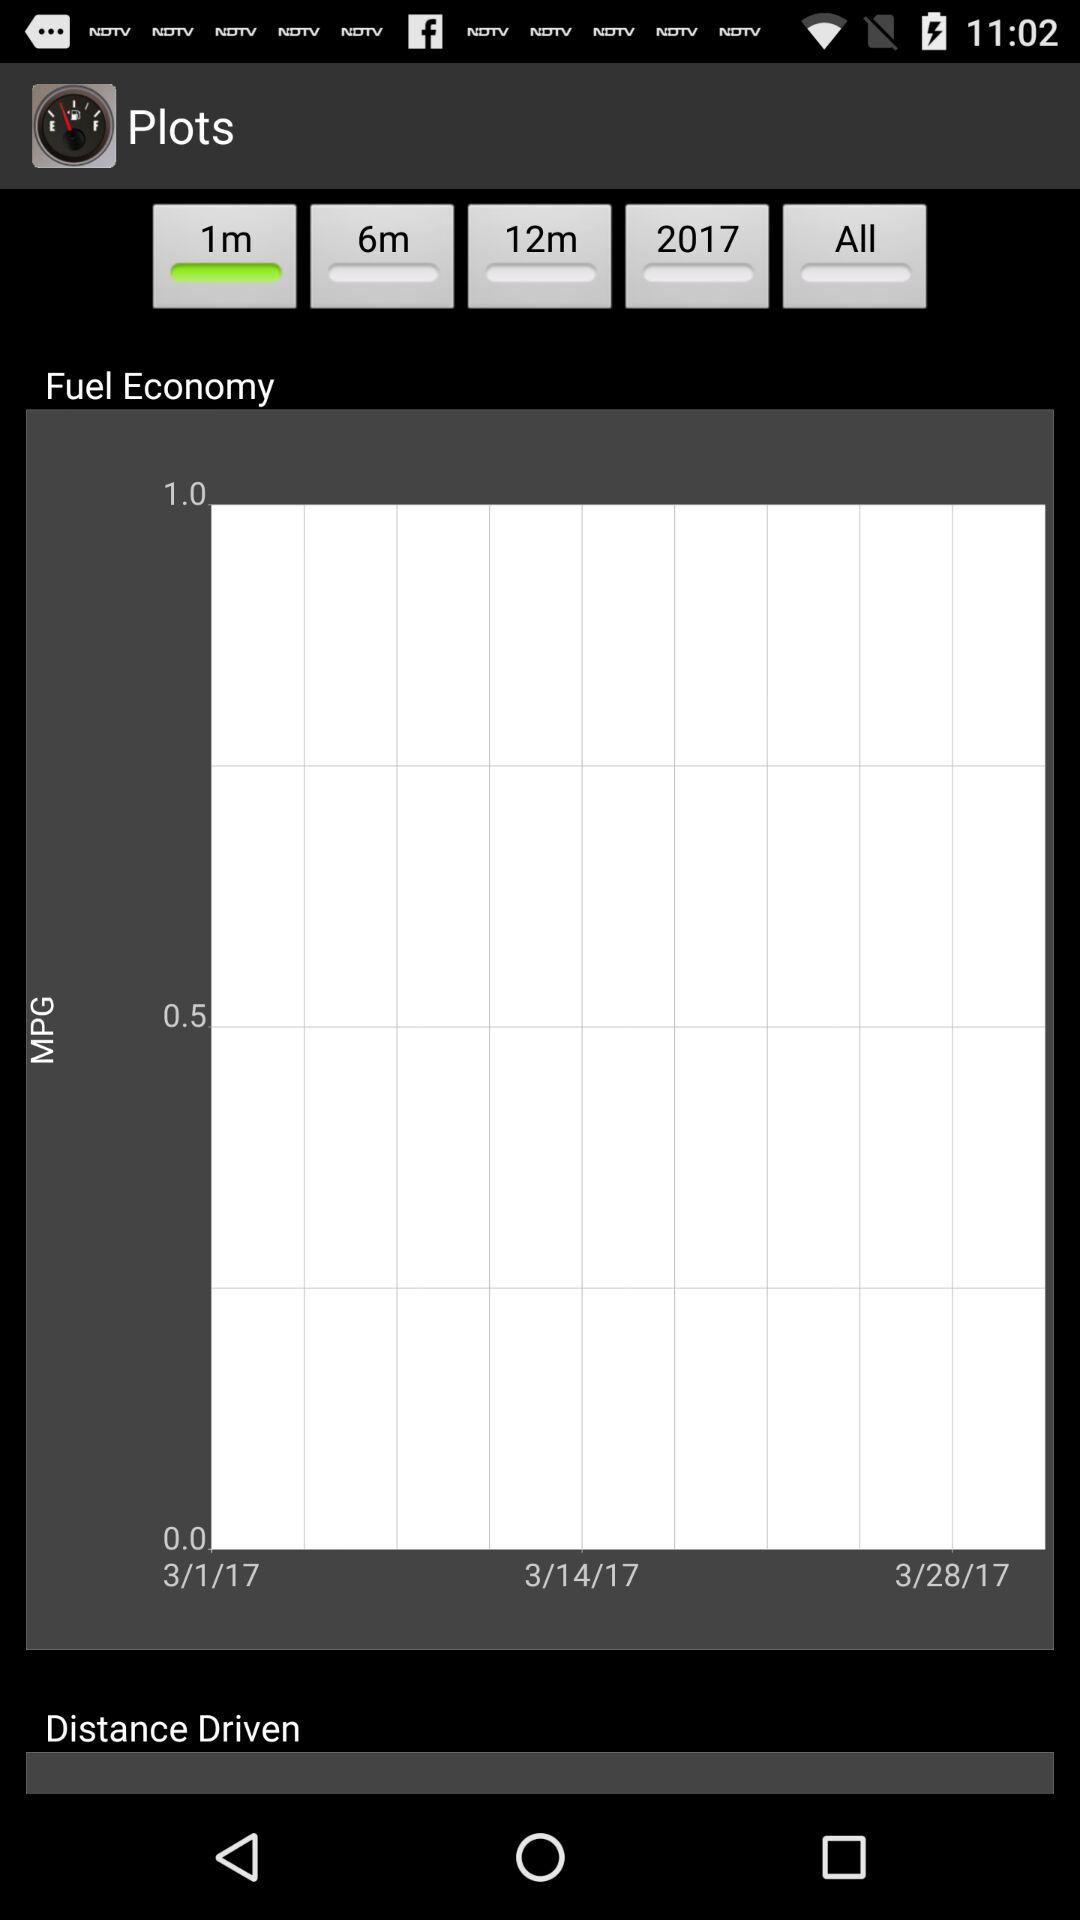How many days does the data span?
Answer the question using a single word or phrase. 28 